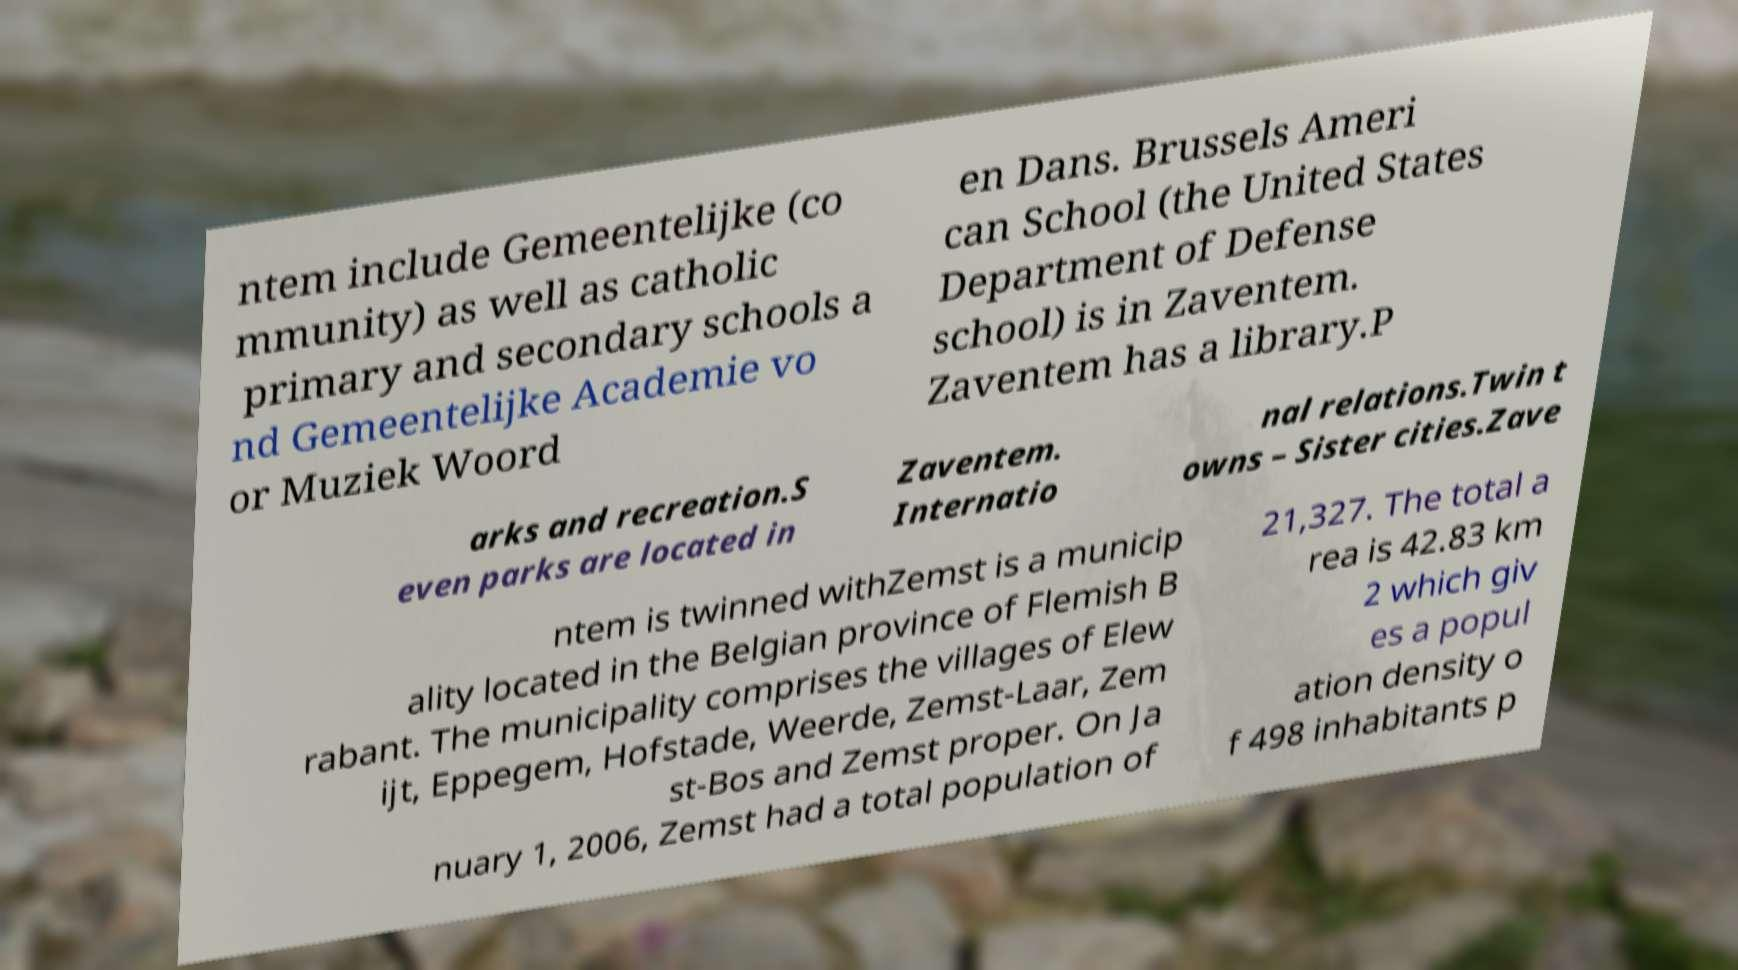For documentation purposes, I need the text within this image transcribed. Could you provide that? ntem include Gemeentelijke (co mmunity) as well as catholic primary and secondary schools a nd Gemeentelijke Academie vo or Muziek Woord en Dans. Brussels Ameri can School (the United States Department of Defense school) is in Zaventem. Zaventem has a library.P arks and recreation.S even parks are located in Zaventem. Internatio nal relations.Twin t owns – Sister cities.Zave ntem is twinned withZemst is a municip ality located in the Belgian province of Flemish B rabant. The municipality comprises the villages of Elew ijt, Eppegem, Hofstade, Weerde, Zemst-Laar, Zem st-Bos and Zemst proper. On Ja nuary 1, 2006, Zemst had a total population of 21,327. The total a rea is 42.83 km 2 which giv es a popul ation density o f 498 inhabitants p 